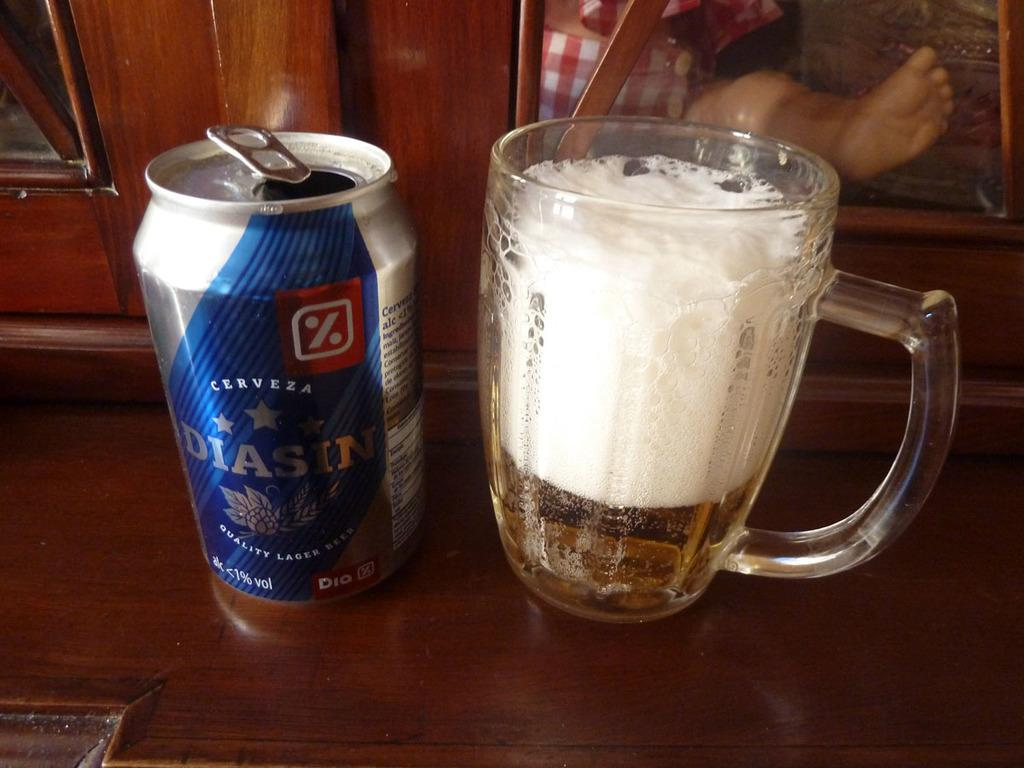What is the main object in the center of the image? There is a table in the center of the image. What can be found on the table? There is a can and a glass on the table. What is visible in the background of the image? There is a door and a human leg visible in the background of the image, along with a few other objects. How much money is being exchanged between the children in the image? There are no children present in the image, and therefore no money exchange can be observed. 